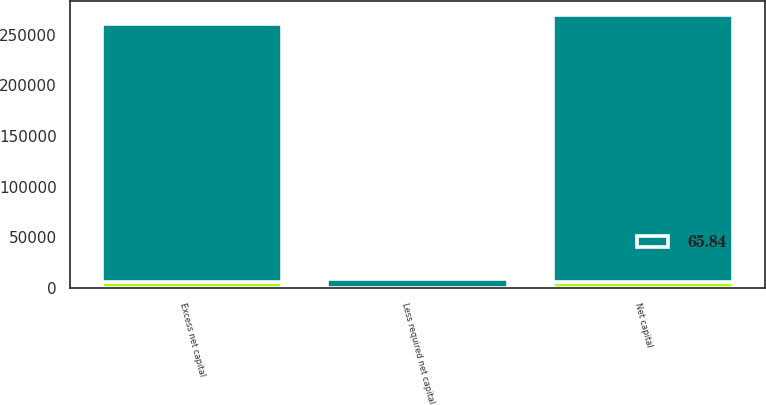<chart> <loc_0><loc_0><loc_500><loc_500><stacked_bar_chart><ecel><fcel>Net capital<fcel>Less required net capital<fcel>Excess net capital<nl><fcel>nan<fcel>6047<fcel>250<fcel>5797<nl><fcel>65.84<fcel>263366<fcel>8432<fcel>254934<nl></chart> 